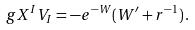Convert formula to latex. <formula><loc_0><loc_0><loc_500><loc_500>g X ^ { I } V _ { I } = - e ^ { - W } ( W ^ { \prime } + r ^ { - 1 } ) \, .</formula> 